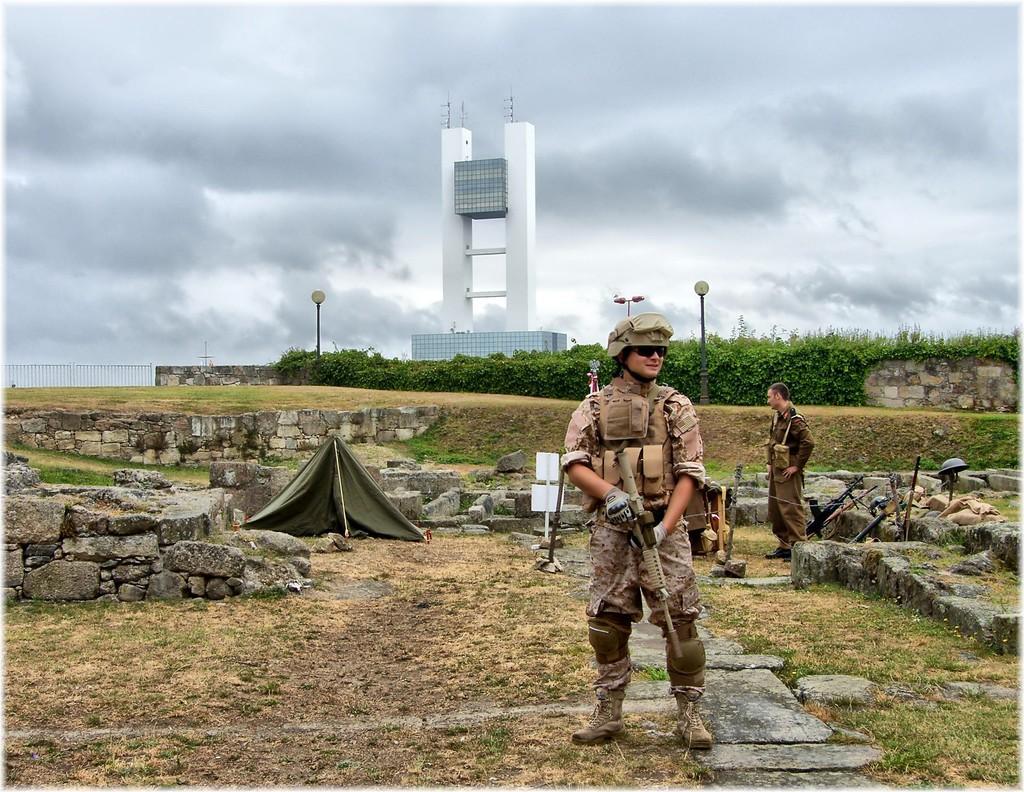Please provide a concise description of this image. In this picture I can see a person holding the weapon. I can see the weapons on the right side. I can see a person standing on the right side. I can see the plants. I can see the metal fence on the left side. I can see the wall. I can see clouds in the sky. I can see the pillar construction. 